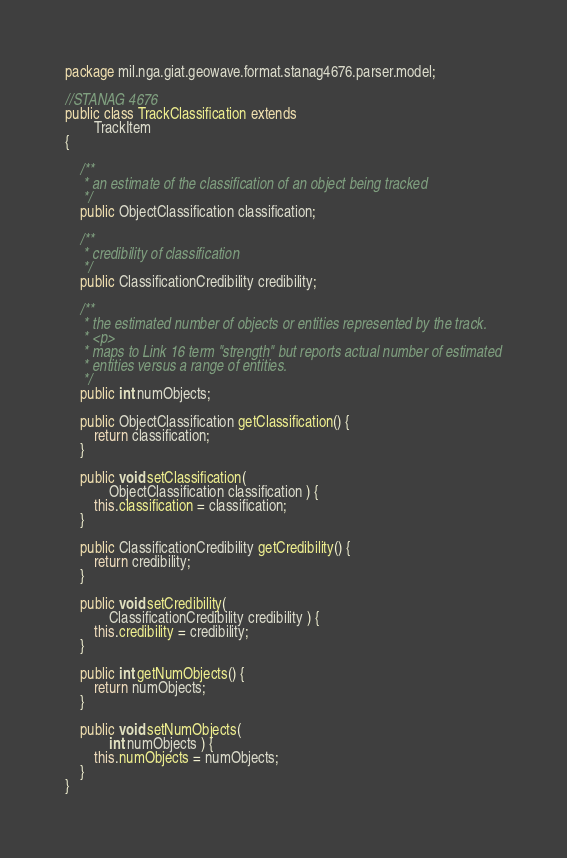Convert code to text. <code><loc_0><loc_0><loc_500><loc_500><_Java_>package mil.nga.giat.geowave.format.stanag4676.parser.model;

//STANAG 4676
public class TrackClassification extends
		TrackItem
{

	/**
	 * an estimate of the classification of an object being tracked
	 */
	public ObjectClassification classification;

	/**
	 * credibility of classification
	 */
	public ClassificationCredibility credibility;

	/**
	 * the estimated number of objects or entities represented by the track.
	 * <p>
	 * maps to Link 16 term "strength" but reports actual number of estimated
	 * entities versus a range of entities.
	 */
	public int numObjects;

	public ObjectClassification getClassification() {
		return classification;
	}

	public void setClassification(
			ObjectClassification classification ) {
		this.classification = classification;
	}

	public ClassificationCredibility getCredibility() {
		return credibility;
	}

	public void setCredibility(
			ClassificationCredibility credibility ) {
		this.credibility = credibility;
	}

	public int getNumObjects() {
		return numObjects;
	}

	public void setNumObjects(
			int numObjects ) {
		this.numObjects = numObjects;
	}
}</code> 